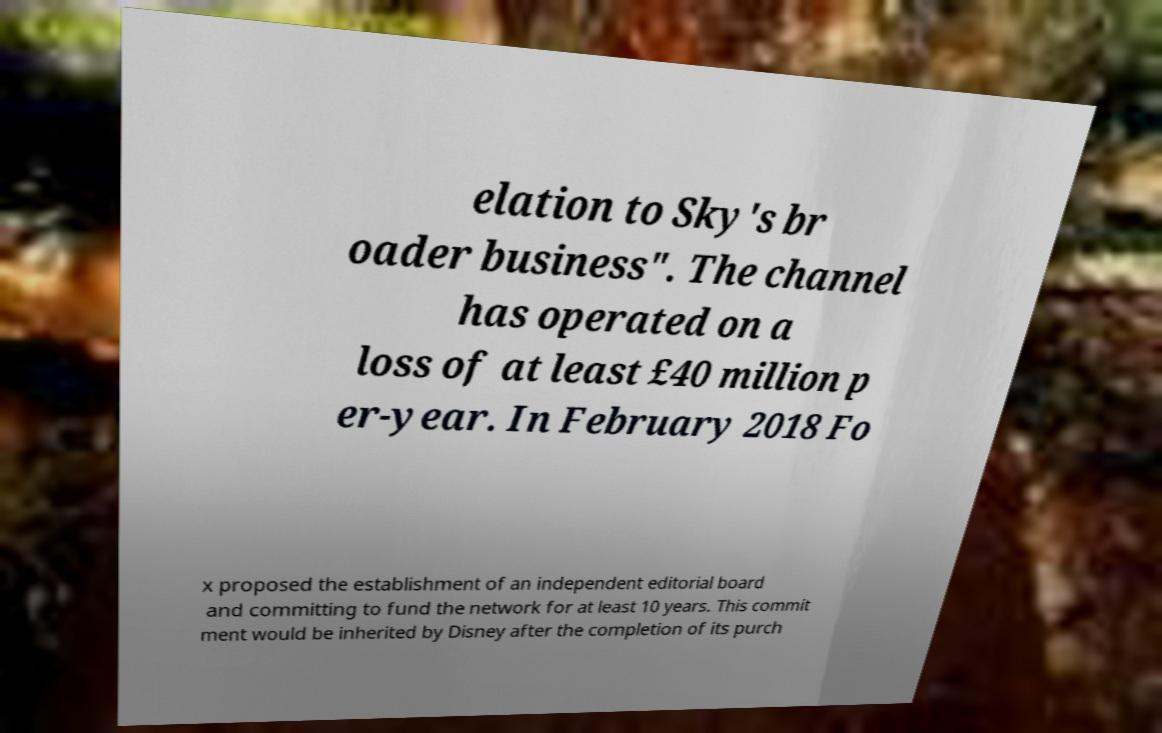Please identify and transcribe the text found in this image. elation to Sky's br oader business". The channel has operated on a loss of at least £40 million p er-year. In February 2018 Fo x proposed the establishment of an independent editorial board and committing to fund the network for at least 10 years. This commit ment would be inherited by Disney after the completion of its purch 